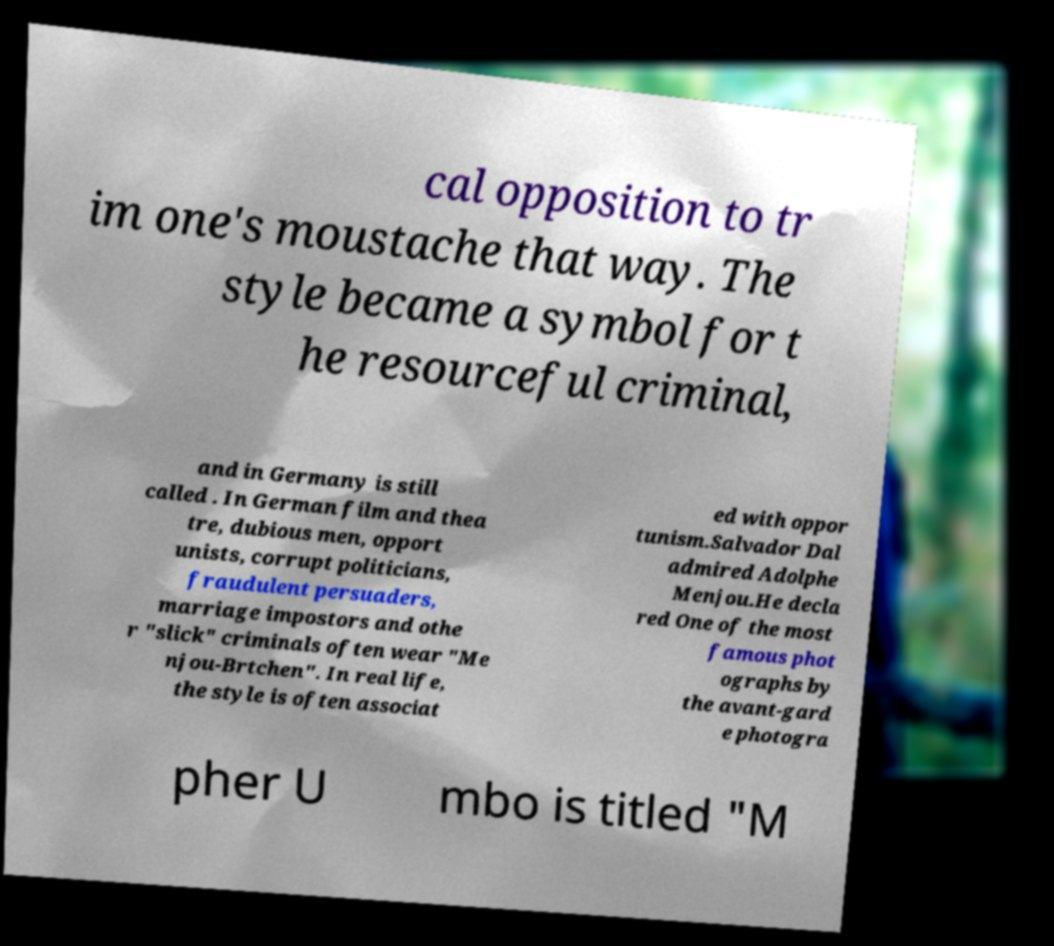Can you read and provide the text displayed in the image?This photo seems to have some interesting text. Can you extract and type it out for me? cal opposition to tr im one's moustache that way. The style became a symbol for t he resourceful criminal, and in Germany is still called . In German film and thea tre, dubious men, opport unists, corrupt politicians, fraudulent persuaders, marriage impostors and othe r "slick" criminals often wear "Me njou-Brtchen". In real life, the style is often associat ed with oppor tunism.Salvador Dal admired Adolphe Menjou.He decla red One of the most famous phot ographs by the avant-gard e photogra pher U mbo is titled "M 